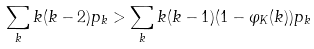Convert formula to latex. <formula><loc_0><loc_0><loc_500><loc_500>\sum _ { k } k ( k - 2 ) p _ { k } > \sum _ { k } k ( k - 1 ) ( 1 - \varphi _ { K } ( k ) ) p _ { k }</formula> 